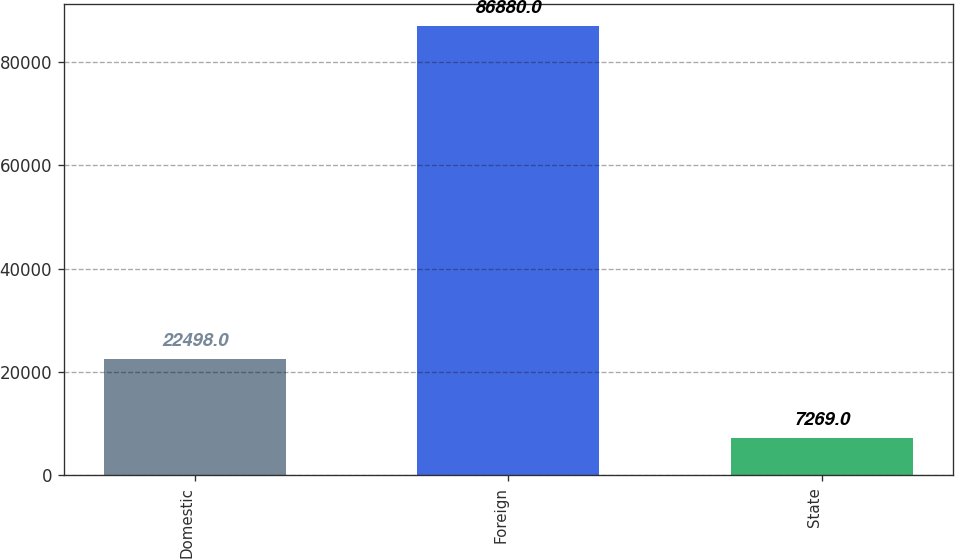Convert chart. <chart><loc_0><loc_0><loc_500><loc_500><bar_chart><fcel>Domestic<fcel>Foreign<fcel>State<nl><fcel>22498<fcel>86880<fcel>7269<nl></chart> 